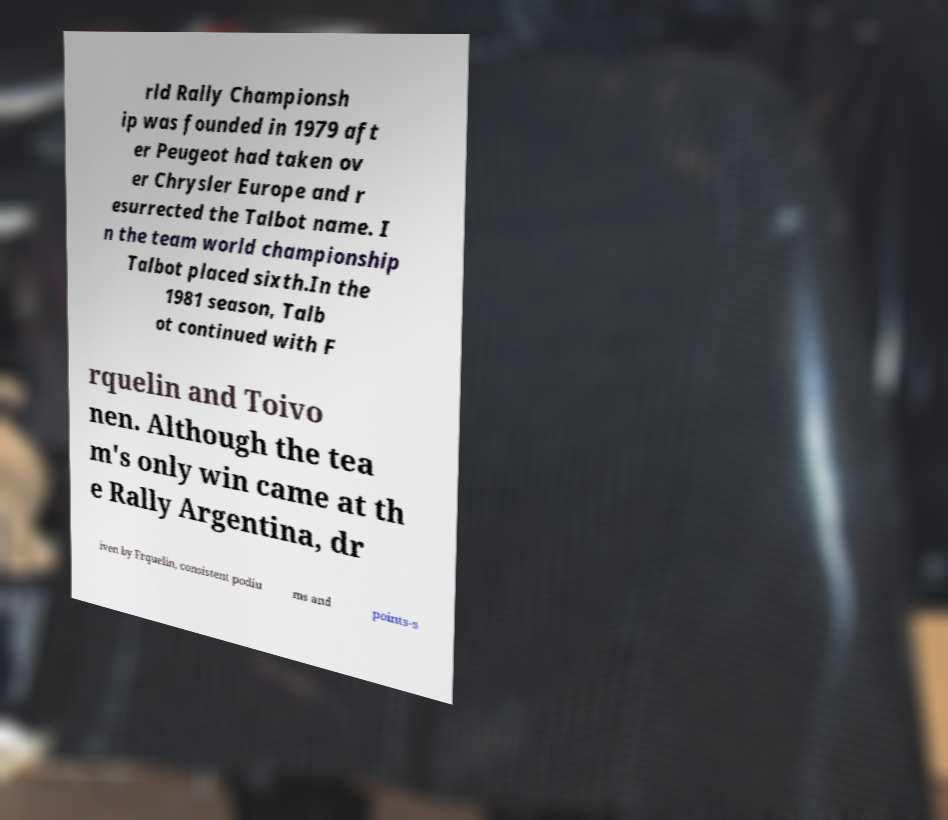For documentation purposes, I need the text within this image transcribed. Could you provide that? rld Rally Championsh ip was founded in 1979 aft er Peugeot had taken ov er Chrysler Europe and r esurrected the Talbot name. I n the team world championship Talbot placed sixth.In the 1981 season, Talb ot continued with F rquelin and Toivo nen. Although the tea m's only win came at th e Rally Argentina, dr iven by Frquelin, consistent podiu ms and points-s 